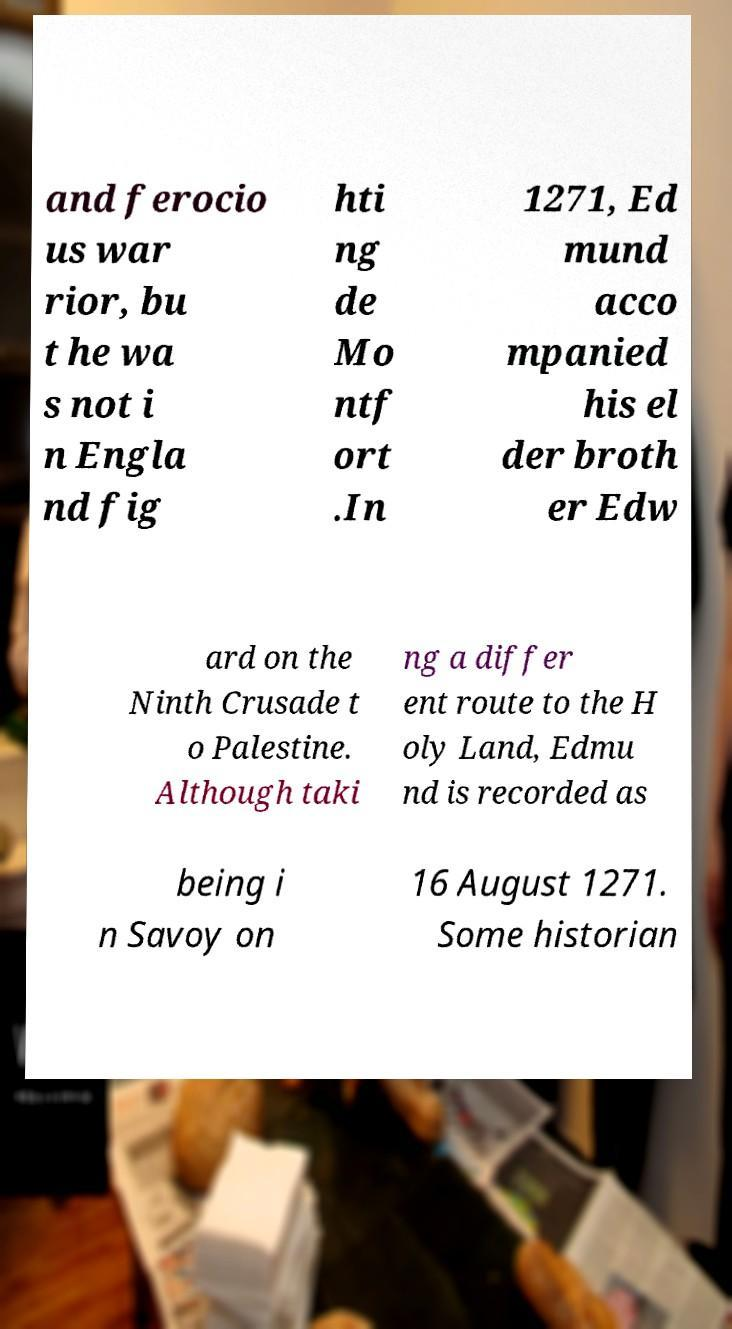Could you assist in decoding the text presented in this image and type it out clearly? and ferocio us war rior, bu t he wa s not i n Engla nd fig hti ng de Mo ntf ort .In 1271, Ed mund acco mpanied his el der broth er Edw ard on the Ninth Crusade t o Palestine. Although taki ng a differ ent route to the H oly Land, Edmu nd is recorded as being i n Savoy on 16 August 1271. Some historian 